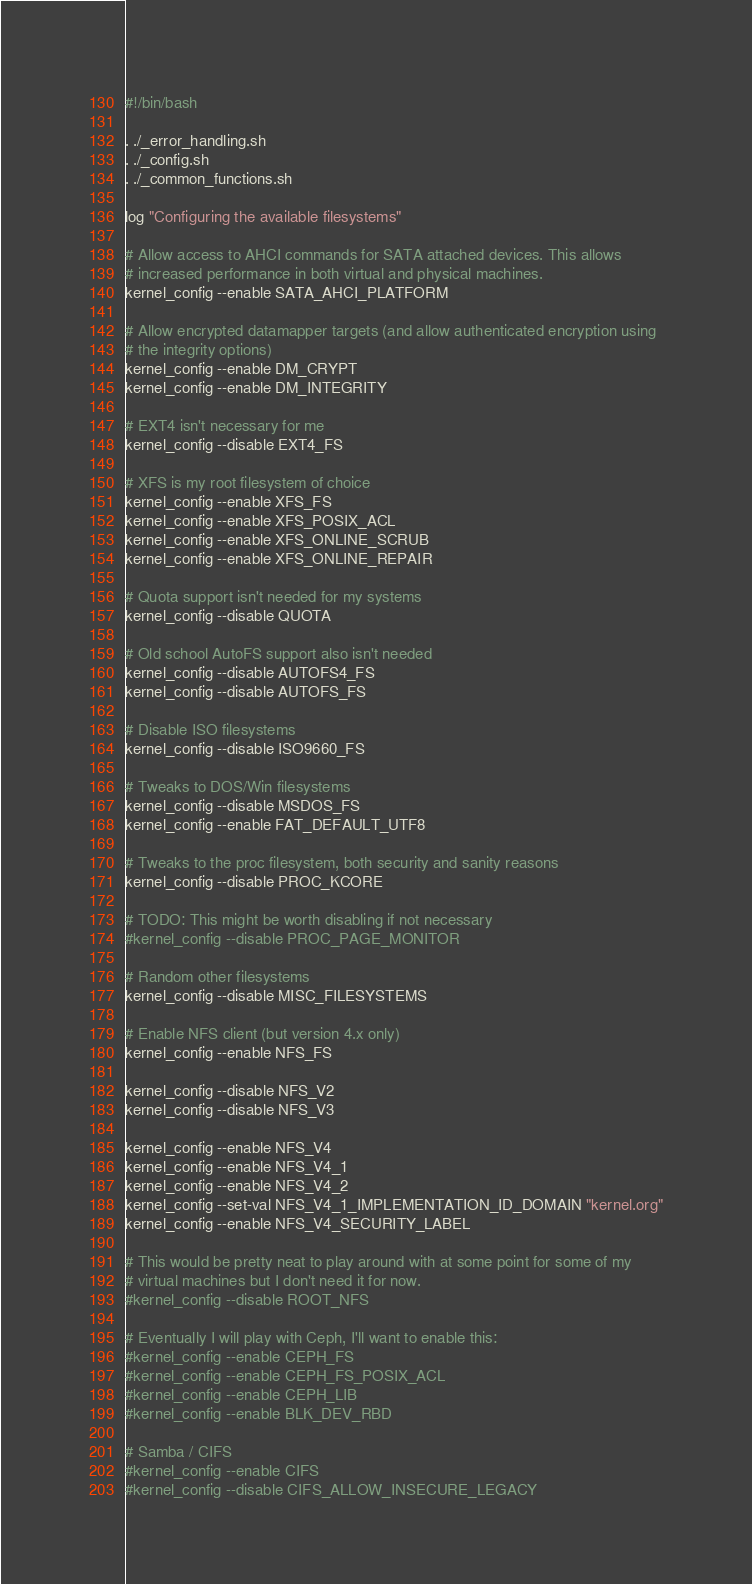Convert code to text. <code><loc_0><loc_0><loc_500><loc_500><_Bash_>#!/bin/bash

. ./_error_handling.sh
. ./_config.sh
. ./_common_functions.sh

log "Configuring the available filesystems"

# Allow access to AHCI commands for SATA attached devices. This allows
# increased performance in both virtual and physical machines.
kernel_config --enable SATA_AHCI_PLATFORM

# Allow encrypted datamapper targets (and allow authenticated encryption using
# the integrity options)
kernel_config --enable DM_CRYPT
kernel_config --enable DM_INTEGRITY

# EXT4 isn't necessary for me
kernel_config --disable EXT4_FS

# XFS is my root filesystem of choice
kernel_config --enable XFS_FS
kernel_config --enable XFS_POSIX_ACL
kernel_config --enable XFS_ONLINE_SCRUB
kernel_config --enable XFS_ONLINE_REPAIR

# Quota support isn't needed for my systems
kernel_config --disable QUOTA

# Old school AutoFS support also isn't needed
kernel_config --disable AUTOFS4_FS
kernel_config --disable AUTOFS_FS

# Disable ISO filesystems
kernel_config --disable ISO9660_FS

# Tweaks to DOS/Win filesystems
kernel_config --disable MSDOS_FS
kernel_config --enable FAT_DEFAULT_UTF8

# Tweaks to the proc filesystem, both security and sanity reasons
kernel_config --disable PROC_KCORE

# TODO: This might be worth disabling if not necessary
#kernel_config --disable PROC_PAGE_MONITOR

# Random other filesystems
kernel_config --disable MISC_FILESYSTEMS

# Enable NFS client (but version 4.x only)
kernel_config --enable NFS_FS

kernel_config --disable NFS_V2
kernel_config --disable NFS_V3

kernel_config --enable NFS_V4
kernel_config --enable NFS_V4_1
kernel_config --enable NFS_V4_2
kernel_config --set-val NFS_V4_1_IMPLEMENTATION_ID_DOMAIN "kernel.org"
kernel_config --enable NFS_V4_SECURITY_LABEL

# This would be pretty neat to play around with at some point for some of my
# virtual machines but I don't need it for now.
#kernel_config --disable ROOT_NFS

# Eventually I will play with Ceph, I'll want to enable this:
#kernel_config --enable CEPH_FS
#kernel_config --enable CEPH_FS_POSIX_ACL
#kernel_config --enable CEPH_LIB
#kernel_config --enable BLK_DEV_RBD

# Samba / CIFS
#kernel_config --enable CIFS
#kernel_config --disable CIFS_ALLOW_INSECURE_LEGACY</code> 